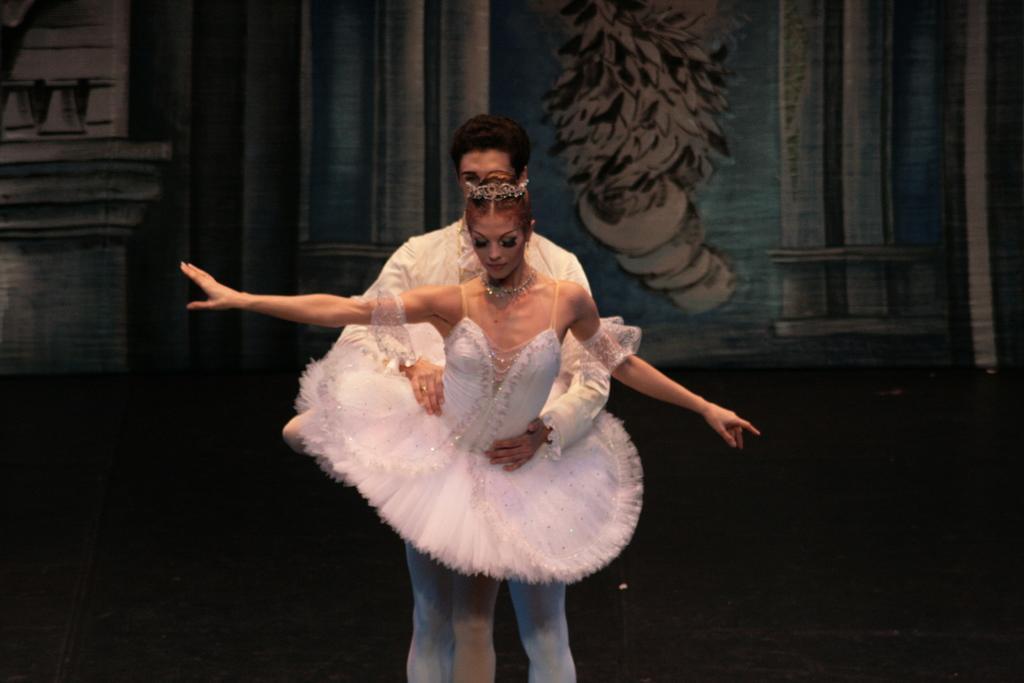How would you summarize this image in a sentence or two? This picture is clicked inside. In the center there is a woman wearing a white color frock and a person wearing a white color dress and both of them are standing and seems to be dancing. In the background we can see the curtain and the wall. 